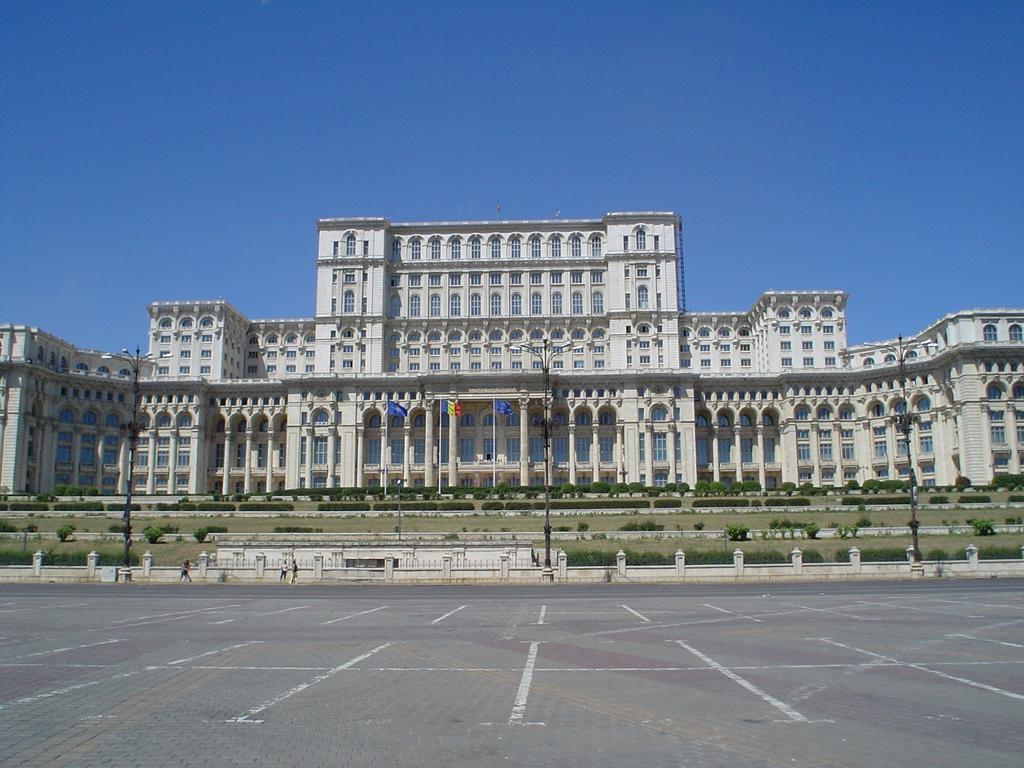Please provide a concise description of this image. In this image we can see buildings, windows, pillars, there are light poles, flags, plants, there are a few people, also we can see the sky. 